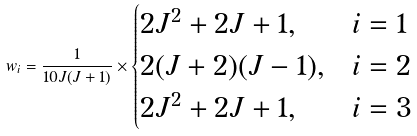<formula> <loc_0><loc_0><loc_500><loc_500>w _ { i } = \frac { 1 } { 1 0 J ( J + 1 ) } \times \begin{cases} 2 J ^ { 2 } + 2 J + 1 , & i = 1 \\ 2 ( J + 2 ) ( J - 1 ) , & i = 2 \\ 2 J ^ { 2 } + 2 J + 1 , & i = 3 \end{cases}</formula> 